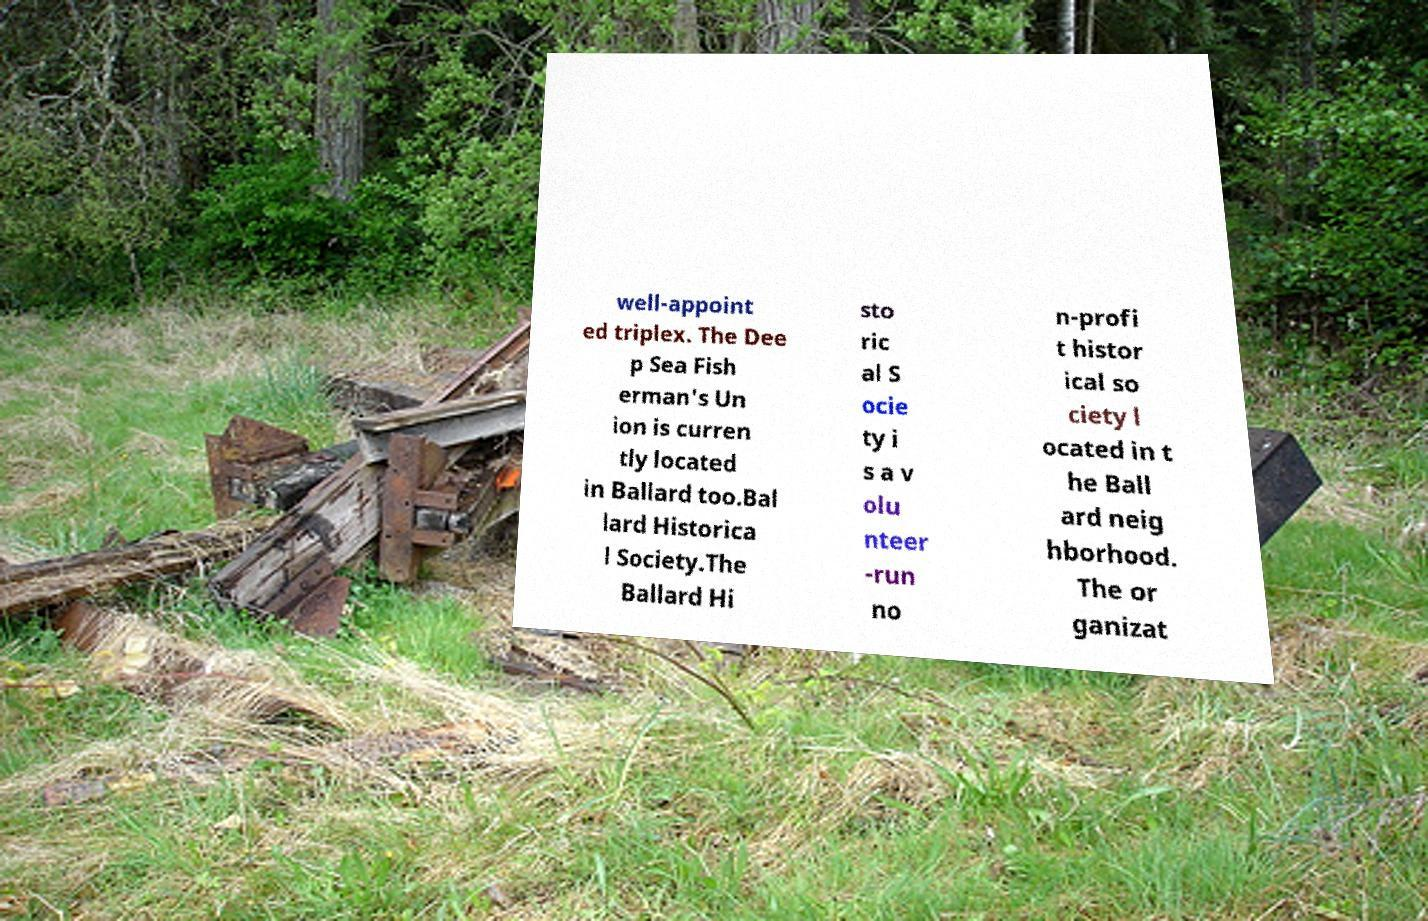For documentation purposes, I need the text within this image transcribed. Could you provide that? well-appoint ed triplex. The Dee p Sea Fish erman's Un ion is curren tly located in Ballard too.Bal lard Historica l Society.The Ballard Hi sto ric al S ocie ty i s a v olu nteer -run no n-profi t histor ical so ciety l ocated in t he Ball ard neig hborhood. The or ganizat 